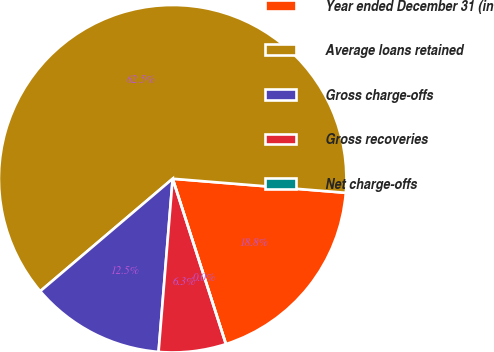Convert chart. <chart><loc_0><loc_0><loc_500><loc_500><pie_chart><fcel>Year ended December 31 (in<fcel>Average loans retained<fcel>Gross charge-offs<fcel>Gross recoveries<fcel>Net charge-offs<nl><fcel>18.75%<fcel>62.49%<fcel>12.5%<fcel>6.25%<fcel>0.0%<nl></chart> 